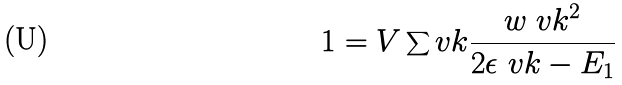<formula> <loc_0><loc_0><loc_500><loc_500>1 = V \sum _ { \ } v k { \frac { w _ { \ } v k ^ { 2 } } { 2 \epsilon _ { \ } v k - E _ { 1 } } }</formula> 